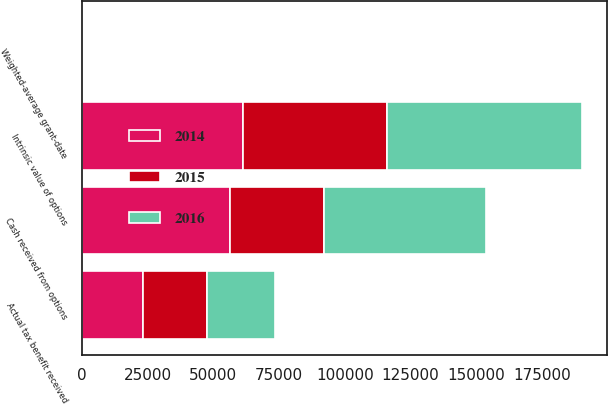<chart> <loc_0><loc_0><loc_500><loc_500><stacked_bar_chart><ecel><fcel>Weighted-average grant-date<fcel>Intrinsic value of options<fcel>Cash received from options<fcel>Actual tax benefit received<nl><fcel>2016<fcel>9.04<fcel>73995<fcel>61329<fcel>25898<nl><fcel>2015<fcel>11.97<fcel>54854<fcel>35958<fcel>24470<nl><fcel>2014<fcel>14.77<fcel>61229<fcel>56294<fcel>23232<nl></chart> 